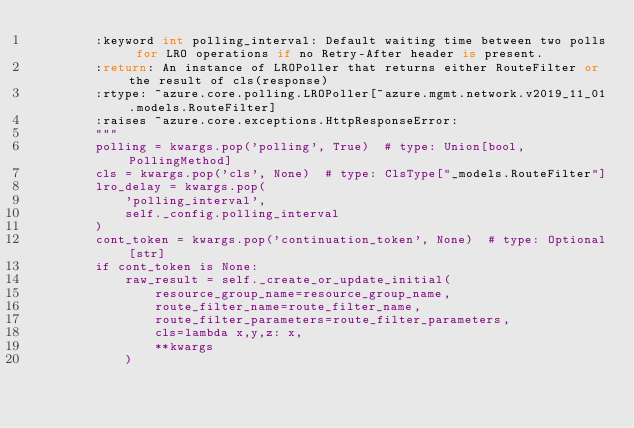<code> <loc_0><loc_0><loc_500><loc_500><_Python_>        :keyword int polling_interval: Default waiting time between two polls for LRO operations if no Retry-After header is present.
        :return: An instance of LROPoller that returns either RouteFilter or the result of cls(response)
        :rtype: ~azure.core.polling.LROPoller[~azure.mgmt.network.v2019_11_01.models.RouteFilter]
        :raises ~azure.core.exceptions.HttpResponseError:
        """
        polling = kwargs.pop('polling', True)  # type: Union[bool, PollingMethod]
        cls = kwargs.pop('cls', None)  # type: ClsType["_models.RouteFilter"]
        lro_delay = kwargs.pop(
            'polling_interval',
            self._config.polling_interval
        )
        cont_token = kwargs.pop('continuation_token', None)  # type: Optional[str]
        if cont_token is None:
            raw_result = self._create_or_update_initial(
                resource_group_name=resource_group_name,
                route_filter_name=route_filter_name,
                route_filter_parameters=route_filter_parameters,
                cls=lambda x,y,z: x,
                **kwargs
            )
</code> 